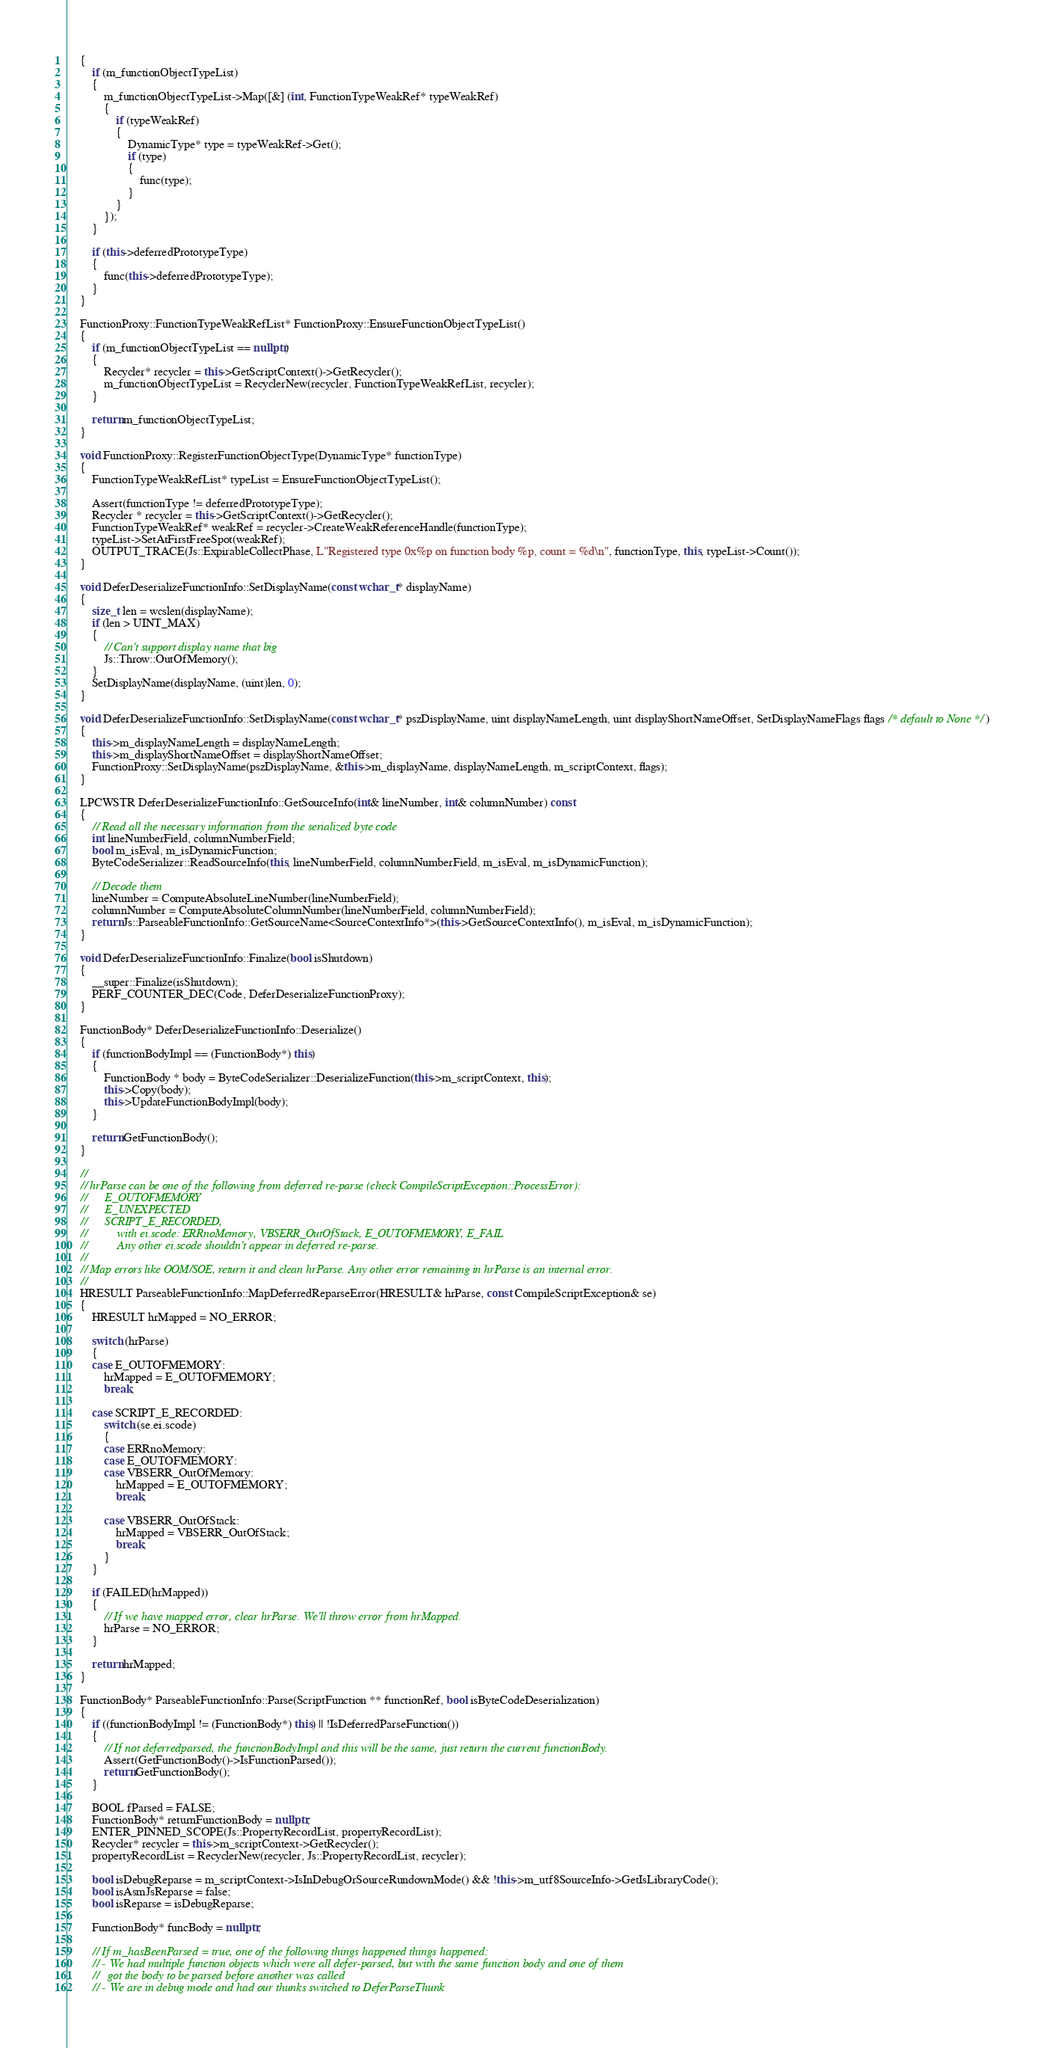Convert code to text. <code><loc_0><loc_0><loc_500><loc_500><_C++_>    {
        if (m_functionObjectTypeList)
        {
            m_functionObjectTypeList->Map([&] (int, FunctionTypeWeakRef* typeWeakRef)
            {
                if (typeWeakRef)
                {
                    DynamicType* type = typeWeakRef->Get();
                    if (type)
                    {
                        func(type);
                    }
                }
            });
        }

        if (this->deferredPrototypeType)
        {
            func(this->deferredPrototypeType);
        }
    }

    FunctionProxy::FunctionTypeWeakRefList* FunctionProxy::EnsureFunctionObjectTypeList()
    {
        if (m_functionObjectTypeList == nullptr)
        {
            Recycler* recycler = this->GetScriptContext()->GetRecycler();
            m_functionObjectTypeList = RecyclerNew(recycler, FunctionTypeWeakRefList, recycler);
        }

        return m_functionObjectTypeList;
    }

    void FunctionProxy::RegisterFunctionObjectType(DynamicType* functionType)
    {
        FunctionTypeWeakRefList* typeList = EnsureFunctionObjectTypeList();

        Assert(functionType != deferredPrototypeType);
        Recycler * recycler = this->GetScriptContext()->GetRecycler();
        FunctionTypeWeakRef* weakRef = recycler->CreateWeakReferenceHandle(functionType);
        typeList->SetAtFirstFreeSpot(weakRef);
        OUTPUT_TRACE(Js::ExpirableCollectPhase, L"Registered type 0x%p on function body %p, count = %d\n", functionType, this, typeList->Count());
    }

    void DeferDeserializeFunctionInfo::SetDisplayName(const wchar_t* displayName)
    {
        size_t len = wcslen(displayName);
        if (len > UINT_MAX)
        {
            // Can't support display name that big
            Js::Throw::OutOfMemory();
        }
        SetDisplayName(displayName, (uint)len, 0);
    }

    void DeferDeserializeFunctionInfo::SetDisplayName(const wchar_t* pszDisplayName, uint displayNameLength, uint displayShortNameOffset, SetDisplayNameFlags flags /* default to None */)
    {
        this->m_displayNameLength = displayNameLength;
        this->m_displayShortNameOffset = displayShortNameOffset;
        FunctionProxy::SetDisplayName(pszDisplayName, &this->m_displayName, displayNameLength, m_scriptContext, flags);
    }

    LPCWSTR DeferDeserializeFunctionInfo::GetSourceInfo(int& lineNumber, int& columnNumber) const
    {
        // Read all the necessary information from the serialized byte code
        int lineNumberField, columnNumberField;
        bool m_isEval, m_isDynamicFunction;
        ByteCodeSerializer::ReadSourceInfo(this, lineNumberField, columnNumberField, m_isEval, m_isDynamicFunction);

        // Decode them
        lineNumber = ComputeAbsoluteLineNumber(lineNumberField);
        columnNumber = ComputeAbsoluteColumnNumber(lineNumberField, columnNumberField);
        return Js::ParseableFunctionInfo::GetSourceName<SourceContextInfo*>(this->GetSourceContextInfo(), m_isEval, m_isDynamicFunction);
    }

    void DeferDeserializeFunctionInfo::Finalize(bool isShutdown)
    {
        __super::Finalize(isShutdown);
        PERF_COUNTER_DEC(Code, DeferDeserializeFunctionProxy);
    }

    FunctionBody* DeferDeserializeFunctionInfo::Deserialize()
    {
        if (functionBodyImpl == (FunctionBody*) this)
        {
            FunctionBody * body = ByteCodeSerializer::DeserializeFunction(this->m_scriptContext, this);
            this->Copy(body);
            this->UpdateFunctionBodyImpl(body);
        }

        return GetFunctionBody();
    }

    //
    // hrParse can be one of the following from deferred re-parse (check CompileScriptException::ProcessError):
    //      E_OUTOFMEMORY
    //      E_UNEXPECTED
    //      SCRIPT_E_RECORDED,
    //          with ei.scode: ERRnoMemory, VBSERR_OutOfStack, E_OUTOFMEMORY, E_FAIL
    //          Any other ei.scode shouldn't appear in deferred re-parse.
    //
    // Map errors like OOM/SOE, return it and clean hrParse. Any other error remaining in hrParse is an internal error.
    //
    HRESULT ParseableFunctionInfo::MapDeferredReparseError(HRESULT& hrParse, const CompileScriptException& se)
    {
        HRESULT hrMapped = NO_ERROR;

        switch (hrParse)
        {
        case E_OUTOFMEMORY:
            hrMapped = E_OUTOFMEMORY;
            break;

        case SCRIPT_E_RECORDED:
            switch (se.ei.scode)
            {
            case ERRnoMemory:
            case E_OUTOFMEMORY:
            case VBSERR_OutOfMemory:
                hrMapped = E_OUTOFMEMORY;
                break;

            case VBSERR_OutOfStack:
                hrMapped = VBSERR_OutOfStack;
                break;
            }
        }

        if (FAILED(hrMapped))
        {
            // If we have mapped error, clear hrParse. We'll throw error from hrMapped.
            hrParse = NO_ERROR;
        }

        return hrMapped;
    }

    FunctionBody* ParseableFunctionInfo::Parse(ScriptFunction ** functionRef, bool isByteCodeDeserialization)
    {
        if ((functionBodyImpl != (FunctionBody*) this) || !IsDeferredParseFunction())
        {
            // If not deferredparsed, the functionBodyImpl and this will be the same, just return the current functionBody.
            Assert(GetFunctionBody()->IsFunctionParsed());
            return GetFunctionBody();
        }

        BOOL fParsed = FALSE;
        FunctionBody* returnFunctionBody = nullptr;
        ENTER_PINNED_SCOPE(Js::PropertyRecordList, propertyRecordList);
        Recycler* recycler = this->m_scriptContext->GetRecycler();
        propertyRecordList = RecyclerNew(recycler, Js::PropertyRecordList, recycler);

        bool isDebugReparse = m_scriptContext->IsInDebugOrSourceRundownMode() && !this->m_utf8SourceInfo->GetIsLibraryCode();
        bool isAsmJsReparse = false;
        bool isReparse = isDebugReparse;

        FunctionBody* funcBody = nullptr;

        // If m_hasBeenParsed = true, one of the following things happened things happened:
        // - We had multiple function objects which were all defer-parsed, but with the same function body and one of them
        //   got the body to be parsed before another was called
        // - We are in debug mode and had our thunks switched to DeferParseThunk</code> 